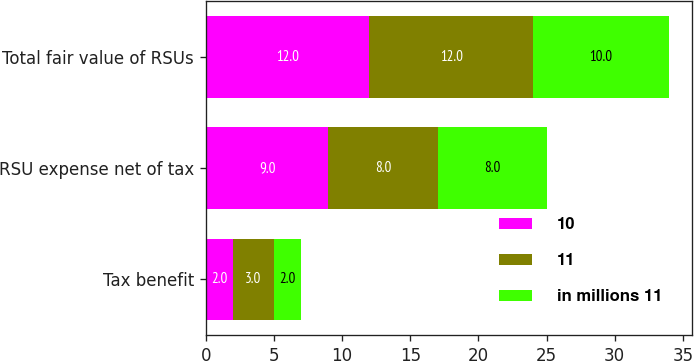Convert chart to OTSL. <chart><loc_0><loc_0><loc_500><loc_500><stacked_bar_chart><ecel><fcel>Tax benefit<fcel>RSU expense net of tax<fcel>Total fair value of RSUs<nl><fcel>10<fcel>2<fcel>9<fcel>12<nl><fcel>11<fcel>3<fcel>8<fcel>12<nl><fcel>in millions 11<fcel>2<fcel>8<fcel>10<nl></chart> 